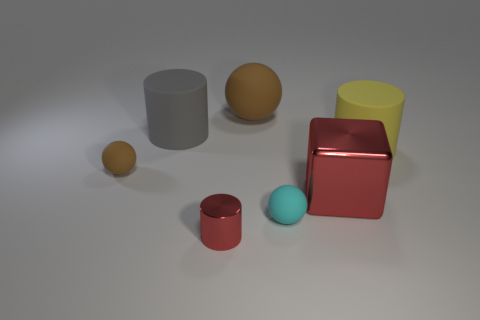Add 2 tiny matte things. How many objects exist? 9 Subtract all spheres. How many objects are left? 4 Add 3 tiny brown objects. How many tiny brown objects exist? 4 Subtract 0 green blocks. How many objects are left? 7 Subtract all large metallic blocks. Subtract all cyan balls. How many objects are left? 5 Add 7 tiny red metal cylinders. How many tiny red metal cylinders are left? 8 